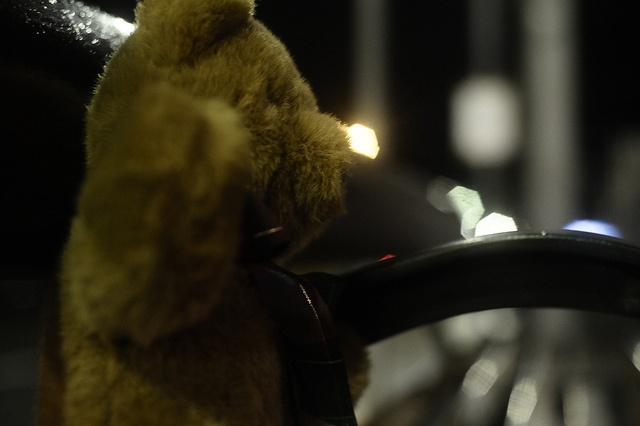Describe the objects in this image and their specific colors. I can see a teddy bear in black and olive tones in this image. 